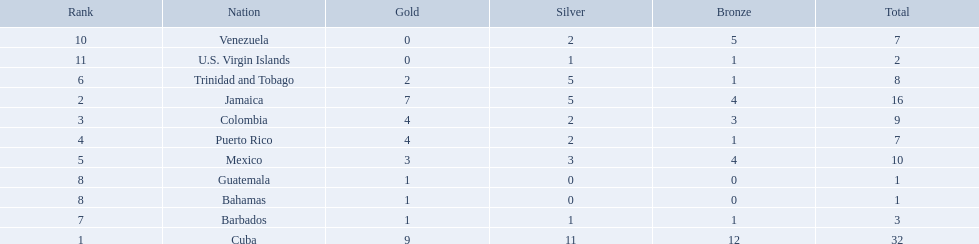Which 3 countries were awarded the most medals? Cuba, Jamaica, Colombia. Of these 3 countries which ones are islands? Cuba, Jamaica. Which one won the most silver medals? Cuba. What teams had four gold medals? Colombia, Puerto Rico. Of these two, which team only had one bronze medal? Puerto Rico. 